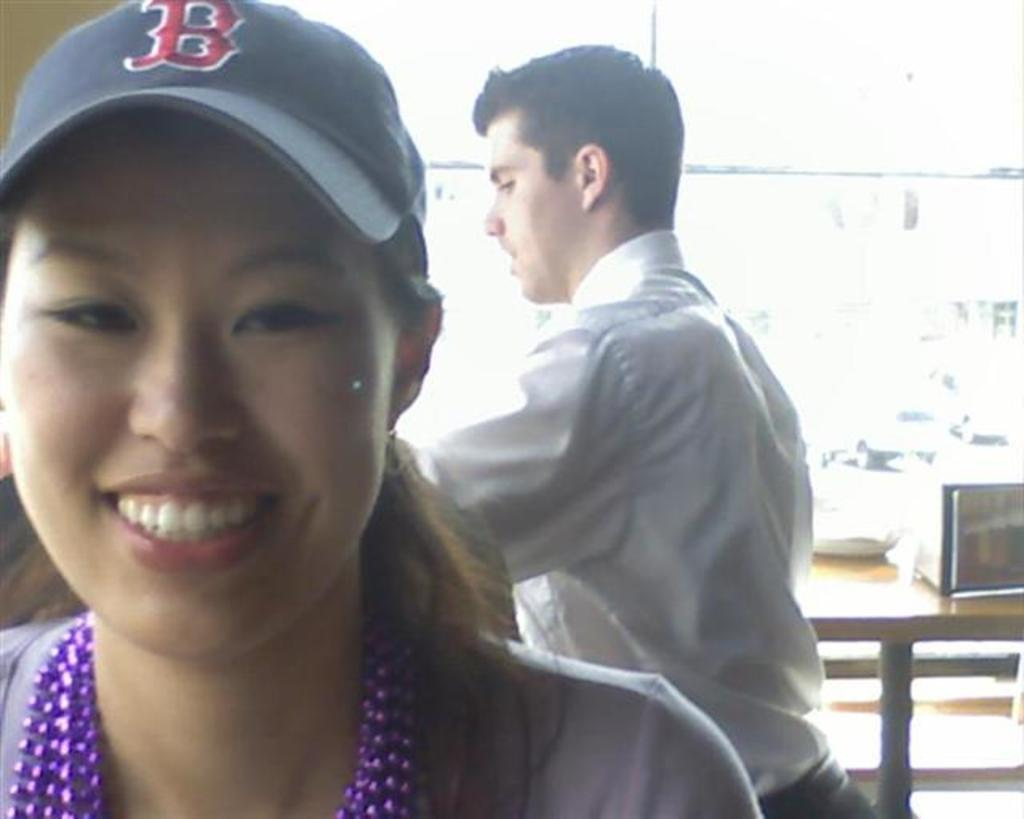<image>
Present a compact description of the photo's key features. A woman is wearing a blue baseball cap with a red letter B. 